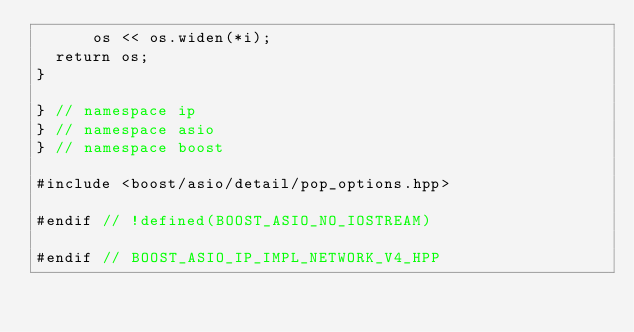<code> <loc_0><loc_0><loc_500><loc_500><_C++_>      os << os.widen(*i);
  return os;
}

} // namespace ip
} // namespace asio
} // namespace boost

#include <boost/asio/detail/pop_options.hpp>

#endif // !defined(BOOST_ASIO_NO_IOSTREAM)

#endif // BOOST_ASIO_IP_IMPL_NETWORK_V4_HPP
</code> 